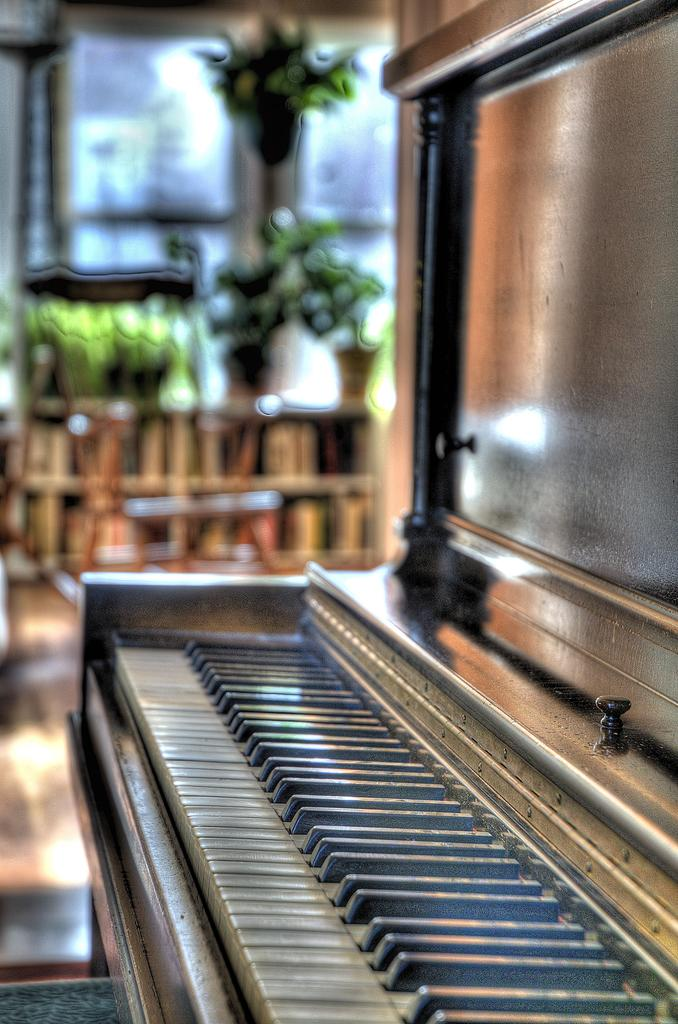What is the main subject of the picture? The main subject of the picture is a piano keyboard. How is the piano keyboard being emphasized in the image? The piano keyboard is highlighted in the picture. What is the chance of the sisters winning the amusement park contest in the image? There is no mention of sisters or an amusement park contest in the image, so it is not possible to determine the chance of them winning. 